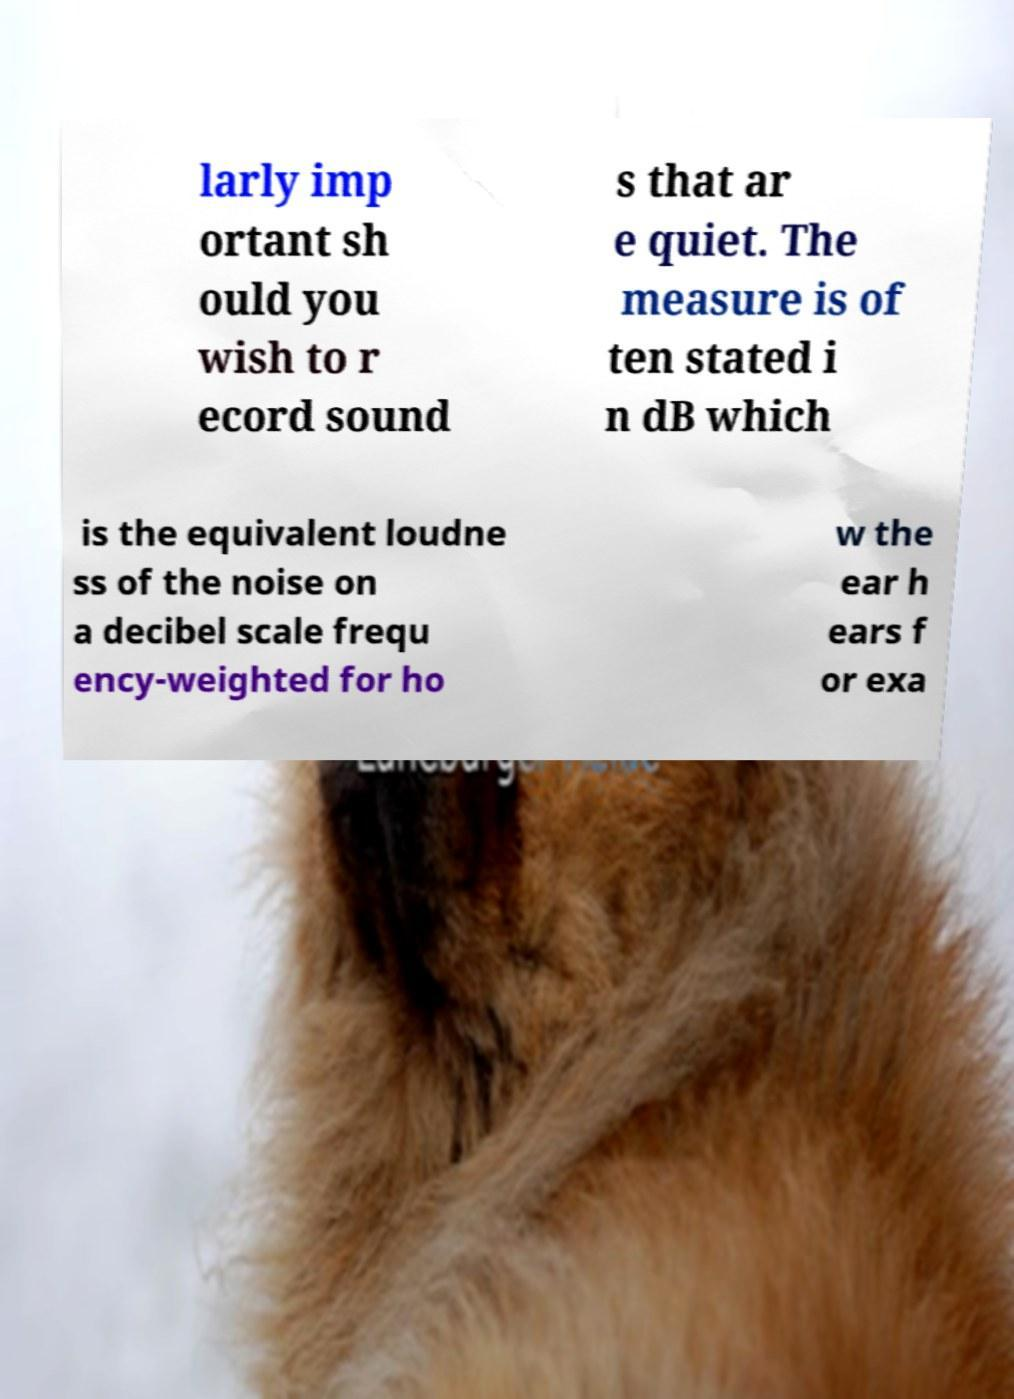Please identify and transcribe the text found in this image. larly imp ortant sh ould you wish to r ecord sound s that ar e quiet. The measure is of ten stated i n dB which is the equivalent loudne ss of the noise on a decibel scale frequ ency-weighted for ho w the ear h ears f or exa 